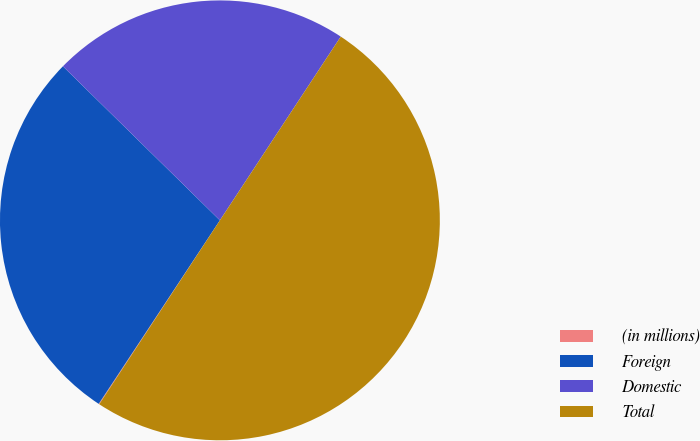Convert chart to OTSL. <chart><loc_0><loc_0><loc_500><loc_500><pie_chart><fcel>(in millions)<fcel>Foreign<fcel>Domestic<fcel>Total<nl><fcel>0.05%<fcel>28.06%<fcel>21.91%<fcel>49.98%<nl></chart> 